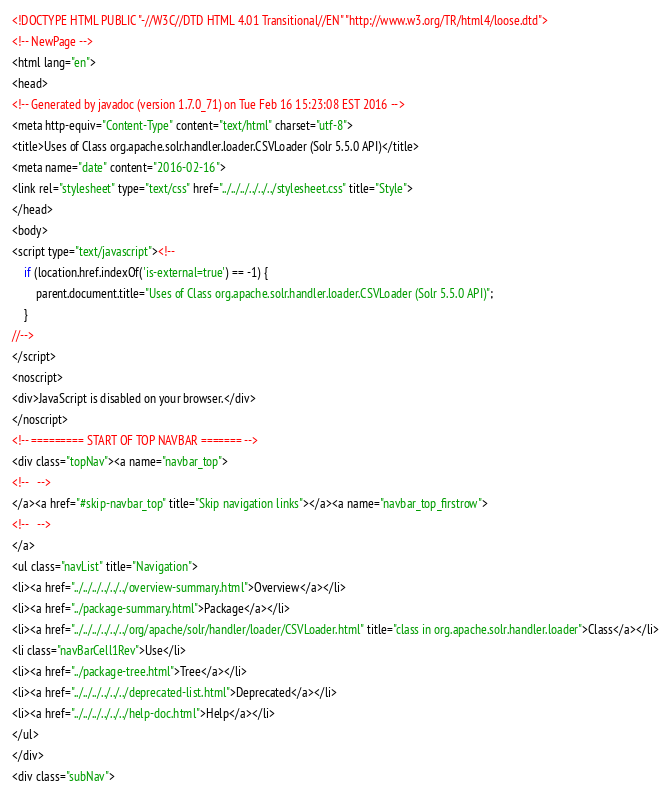<code> <loc_0><loc_0><loc_500><loc_500><_HTML_><!DOCTYPE HTML PUBLIC "-//W3C//DTD HTML 4.01 Transitional//EN" "http://www.w3.org/TR/html4/loose.dtd">
<!-- NewPage -->
<html lang="en">
<head>
<!-- Generated by javadoc (version 1.7.0_71) on Tue Feb 16 15:23:08 EST 2016 -->
<meta http-equiv="Content-Type" content="text/html" charset="utf-8">
<title>Uses of Class org.apache.solr.handler.loader.CSVLoader (Solr 5.5.0 API)</title>
<meta name="date" content="2016-02-16">
<link rel="stylesheet" type="text/css" href="../../../../../../stylesheet.css" title="Style">
</head>
<body>
<script type="text/javascript"><!--
    if (location.href.indexOf('is-external=true') == -1) {
        parent.document.title="Uses of Class org.apache.solr.handler.loader.CSVLoader (Solr 5.5.0 API)";
    }
//-->
</script>
<noscript>
<div>JavaScript is disabled on your browser.</div>
</noscript>
<!-- ========= START OF TOP NAVBAR ======= -->
<div class="topNav"><a name="navbar_top">
<!--   -->
</a><a href="#skip-navbar_top" title="Skip navigation links"></a><a name="navbar_top_firstrow">
<!--   -->
</a>
<ul class="navList" title="Navigation">
<li><a href="../../../../../../overview-summary.html">Overview</a></li>
<li><a href="../package-summary.html">Package</a></li>
<li><a href="../../../../../../org/apache/solr/handler/loader/CSVLoader.html" title="class in org.apache.solr.handler.loader">Class</a></li>
<li class="navBarCell1Rev">Use</li>
<li><a href="../package-tree.html">Tree</a></li>
<li><a href="../../../../../../deprecated-list.html">Deprecated</a></li>
<li><a href="../../../../../../help-doc.html">Help</a></li>
</ul>
</div>
<div class="subNav"></code> 